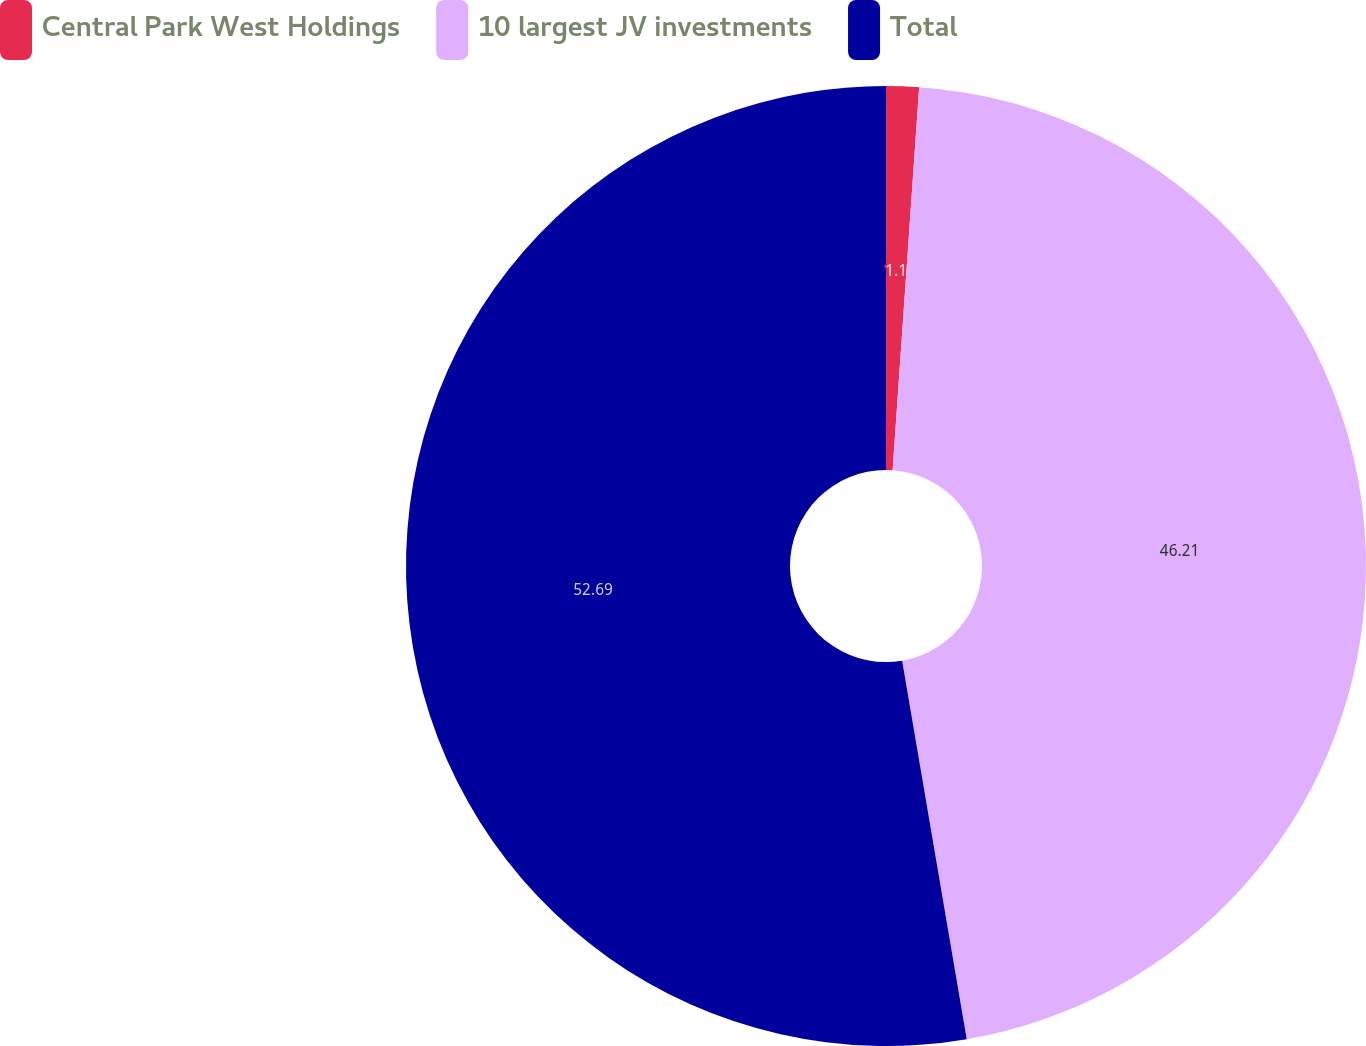Convert chart to OTSL. <chart><loc_0><loc_0><loc_500><loc_500><pie_chart><fcel>Central Park West Holdings<fcel>10 largest JV investments<fcel>Total<nl><fcel>1.1%<fcel>46.21%<fcel>52.69%<nl></chart> 